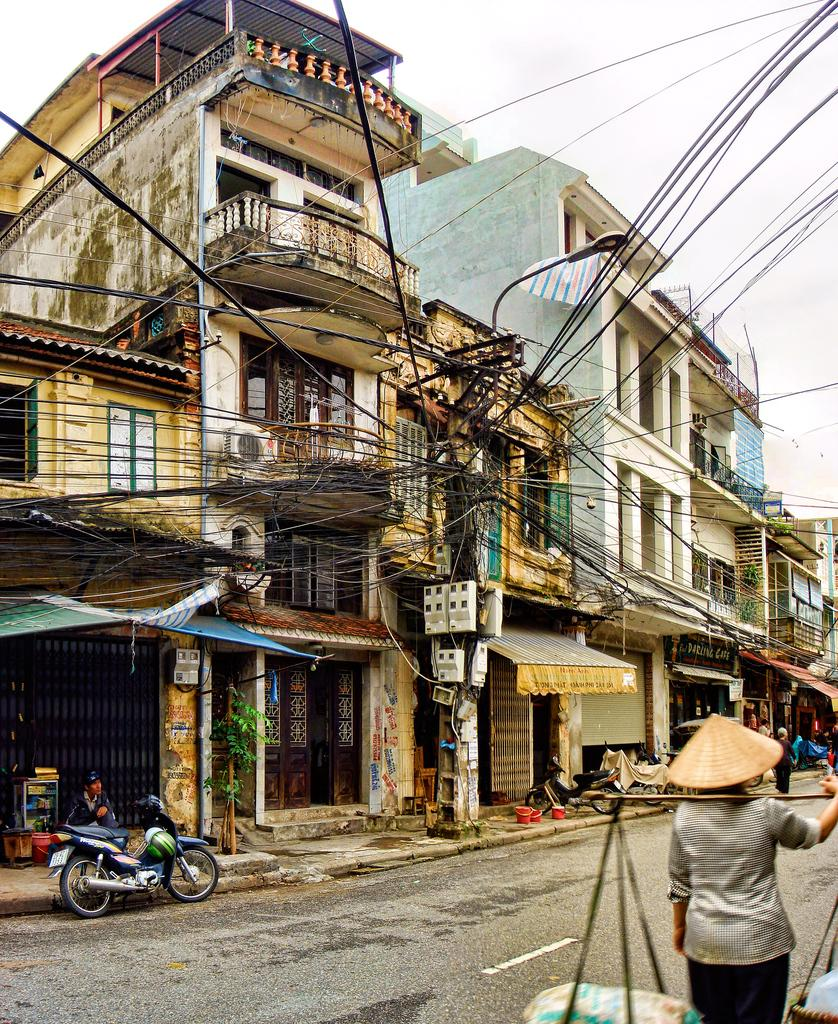What is the main subject of the image? There is a person standing in the image. What is the person doing in the image? The person is holding objects. Where is the person located in the image? The person is in the right corner of the image. What can be seen in the left corner of the image? There are buildings and a pole with wires attached to it in the left corner of the image. What is the person's wealth in the image? There is no information about the person's wealth in the image. --- Facts: 1. There is a person standing in the image. 2. The person is holding a book. 3. The person is wearing a blue shirt. 4. The person is standing in front of a bookshelf. 5. The bookshelf is filled with books. Absurd Topics: elephant, car Conversation: What is the main subject of the image? There is a person standing in the image. What is the person holding in the image? The person is holding a book. What is the person wearing in the image? The person is wearing a blue shirt. What is located behind the person in the image? The person is standing in front of a bookshelf. How many books are visible on the bookshelf in the image? The bookshelf is filled with books, so it is impossible to determine the exact number of books visible on the bookshelf in the image. Reasoning: Let's think step by step in order to produce the conversation. We start by identifying the main subject of the image, which is the person standing. Then, we describe what the person is holding, which is a book. Next, we mention what the person is wearing, which is a blue shirt. After that, we describe the background of the image, which is a bookshelf filled with books. Finally, we avoid asking questions about the exact number of books visible on the bookshelf in the image, as it is impossible to determine that information from the provided facts. Absurd Question/Answer: Can you see an elephant or a car in the image? No, there is no elephant or car visible in the image. --- Facts: 1. There is a person standing in the image. 2. The person is holding a camera. 3. The person is wearing a red hat. 4. The person is standing in front of a landscape. 5. There are trees visible in the background of the image. Absurd Topics: unicorn, rainbow, clouds Conversation: What is the main subject of the image? There is a person standing in the image. What is the person holding in the image? The person is holding a camera. What is the person wearing in the image? The 